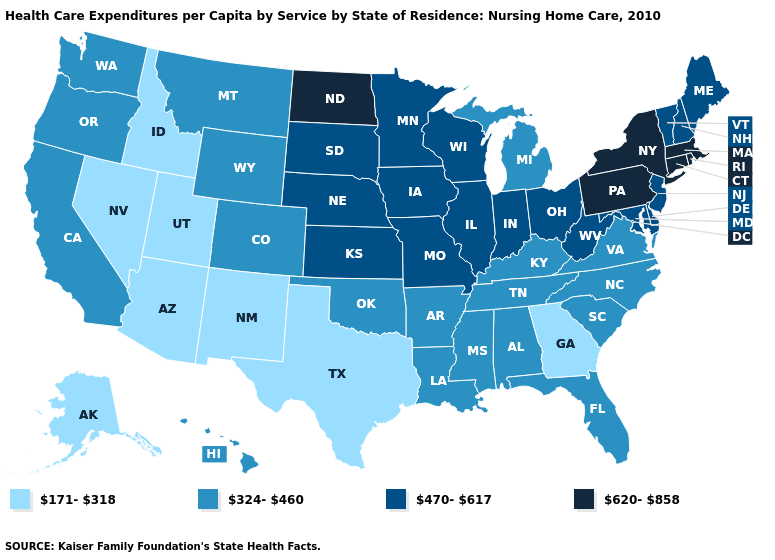What is the highest value in the West ?
Give a very brief answer. 324-460. What is the value of Washington?
Give a very brief answer. 324-460. Which states have the lowest value in the USA?
Concise answer only. Alaska, Arizona, Georgia, Idaho, Nevada, New Mexico, Texas, Utah. Does Minnesota have the lowest value in the MidWest?
Answer briefly. No. Name the states that have a value in the range 620-858?
Be succinct. Connecticut, Massachusetts, New York, North Dakota, Pennsylvania, Rhode Island. What is the value of New Hampshire?
Concise answer only. 470-617. Does Rhode Island have the highest value in the Northeast?
Write a very short answer. Yes. Among the states that border Connecticut , which have the highest value?
Quick response, please. Massachusetts, New York, Rhode Island. What is the value of South Carolina?
Answer briefly. 324-460. Name the states that have a value in the range 171-318?
Keep it brief. Alaska, Arizona, Georgia, Idaho, Nevada, New Mexico, Texas, Utah. Does Florida have a lower value than Arkansas?
Give a very brief answer. No. What is the value of South Carolina?
Quick response, please. 324-460. What is the value of North Dakota?
Be succinct. 620-858. What is the value of West Virginia?
Answer briefly. 470-617. Does North Dakota have the highest value in the USA?
Write a very short answer. Yes. 